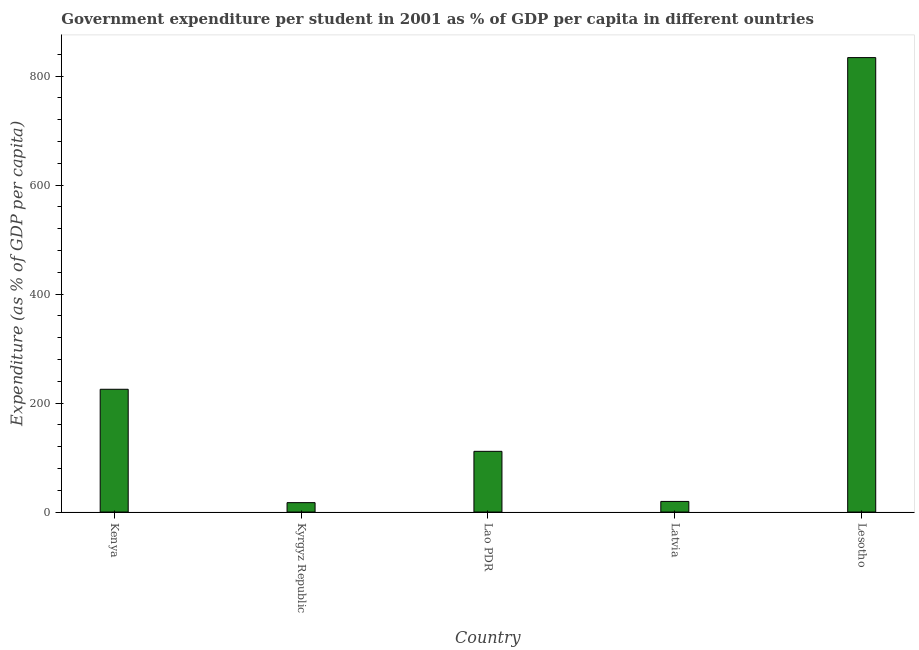Does the graph contain any zero values?
Make the answer very short. No. Does the graph contain grids?
Provide a succinct answer. No. What is the title of the graph?
Provide a short and direct response. Government expenditure per student in 2001 as % of GDP per capita in different ountries. What is the label or title of the X-axis?
Your answer should be very brief. Country. What is the label or title of the Y-axis?
Your response must be concise. Expenditure (as % of GDP per capita). What is the government expenditure per student in Latvia?
Keep it short and to the point. 19.47. Across all countries, what is the maximum government expenditure per student?
Provide a succinct answer. 833.88. Across all countries, what is the minimum government expenditure per student?
Your answer should be compact. 17.23. In which country was the government expenditure per student maximum?
Provide a short and direct response. Lesotho. In which country was the government expenditure per student minimum?
Your response must be concise. Kyrgyz Republic. What is the sum of the government expenditure per student?
Keep it short and to the point. 1207.21. What is the difference between the government expenditure per student in Kyrgyz Republic and Lesotho?
Provide a short and direct response. -816.66. What is the average government expenditure per student per country?
Keep it short and to the point. 241.44. What is the median government expenditure per student?
Your answer should be compact. 111.38. What is the ratio of the government expenditure per student in Kenya to that in Lao PDR?
Your answer should be very brief. 2.02. Is the government expenditure per student in Kyrgyz Republic less than that in Lao PDR?
Offer a very short reply. Yes. Is the difference between the government expenditure per student in Kenya and Kyrgyz Republic greater than the difference between any two countries?
Your answer should be compact. No. What is the difference between the highest and the second highest government expenditure per student?
Your answer should be very brief. 608.63. Is the sum of the government expenditure per student in Kenya and Kyrgyz Republic greater than the maximum government expenditure per student across all countries?
Your answer should be compact. No. What is the difference between the highest and the lowest government expenditure per student?
Your response must be concise. 816.66. How many countries are there in the graph?
Ensure brevity in your answer.  5. What is the difference between two consecutive major ticks on the Y-axis?
Provide a short and direct response. 200. What is the Expenditure (as % of GDP per capita) in Kenya?
Give a very brief answer. 225.25. What is the Expenditure (as % of GDP per capita) in Kyrgyz Republic?
Give a very brief answer. 17.23. What is the Expenditure (as % of GDP per capita) of Lao PDR?
Your response must be concise. 111.38. What is the Expenditure (as % of GDP per capita) of Latvia?
Offer a terse response. 19.47. What is the Expenditure (as % of GDP per capita) in Lesotho?
Ensure brevity in your answer.  833.88. What is the difference between the Expenditure (as % of GDP per capita) in Kenya and Kyrgyz Republic?
Keep it short and to the point. 208.03. What is the difference between the Expenditure (as % of GDP per capita) in Kenya and Lao PDR?
Your answer should be very brief. 113.88. What is the difference between the Expenditure (as % of GDP per capita) in Kenya and Latvia?
Provide a succinct answer. 205.78. What is the difference between the Expenditure (as % of GDP per capita) in Kenya and Lesotho?
Your answer should be compact. -608.63. What is the difference between the Expenditure (as % of GDP per capita) in Kyrgyz Republic and Lao PDR?
Offer a terse response. -94.15. What is the difference between the Expenditure (as % of GDP per capita) in Kyrgyz Republic and Latvia?
Make the answer very short. -2.25. What is the difference between the Expenditure (as % of GDP per capita) in Kyrgyz Republic and Lesotho?
Ensure brevity in your answer.  -816.66. What is the difference between the Expenditure (as % of GDP per capita) in Lao PDR and Latvia?
Your response must be concise. 91.9. What is the difference between the Expenditure (as % of GDP per capita) in Lao PDR and Lesotho?
Your answer should be very brief. -722.51. What is the difference between the Expenditure (as % of GDP per capita) in Latvia and Lesotho?
Your answer should be compact. -814.41. What is the ratio of the Expenditure (as % of GDP per capita) in Kenya to that in Kyrgyz Republic?
Offer a very short reply. 13.08. What is the ratio of the Expenditure (as % of GDP per capita) in Kenya to that in Lao PDR?
Offer a terse response. 2.02. What is the ratio of the Expenditure (as % of GDP per capita) in Kenya to that in Latvia?
Provide a short and direct response. 11.57. What is the ratio of the Expenditure (as % of GDP per capita) in Kenya to that in Lesotho?
Offer a terse response. 0.27. What is the ratio of the Expenditure (as % of GDP per capita) in Kyrgyz Republic to that in Lao PDR?
Give a very brief answer. 0.15. What is the ratio of the Expenditure (as % of GDP per capita) in Kyrgyz Republic to that in Latvia?
Give a very brief answer. 0.89. What is the ratio of the Expenditure (as % of GDP per capita) in Kyrgyz Republic to that in Lesotho?
Make the answer very short. 0.02. What is the ratio of the Expenditure (as % of GDP per capita) in Lao PDR to that in Latvia?
Keep it short and to the point. 5.72. What is the ratio of the Expenditure (as % of GDP per capita) in Lao PDR to that in Lesotho?
Your answer should be very brief. 0.13. What is the ratio of the Expenditure (as % of GDP per capita) in Latvia to that in Lesotho?
Provide a short and direct response. 0.02. 